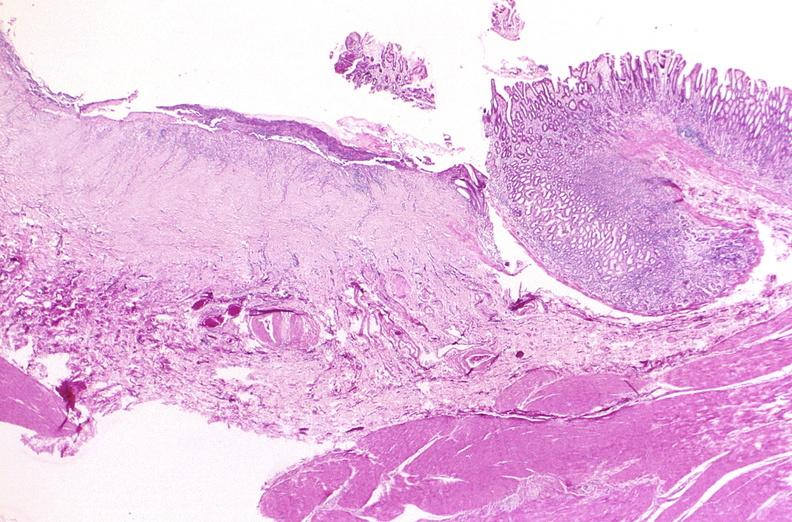does this image show stomach, chronic peptic ulcer?
Answer the question using a single word or phrase. Yes 